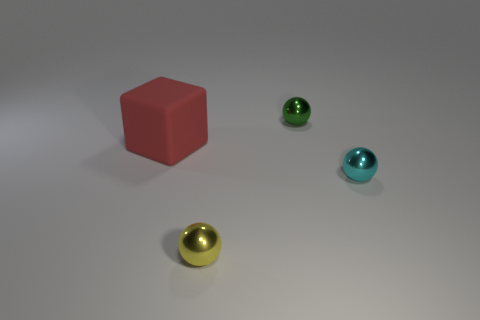Add 2 yellow spheres. How many objects exist? 6 Subtract all blocks. How many objects are left? 3 Add 4 tiny matte things. How many tiny matte things exist? 4 Subtract 0 cyan cylinders. How many objects are left? 4 Subtract all cyan rubber blocks. Subtract all big red matte cubes. How many objects are left? 3 Add 3 cyan spheres. How many cyan spheres are left? 4 